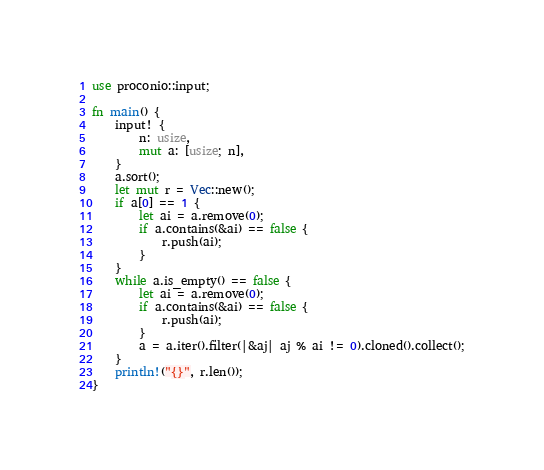Convert code to text. <code><loc_0><loc_0><loc_500><loc_500><_Rust_>use proconio::input;

fn main() {
    input! {
        n: usize,
        mut a: [usize; n],
    }
    a.sort();
    let mut r = Vec::new();
    if a[0] == 1 {
        let ai = a.remove(0);
        if a.contains(&ai) == false {
            r.push(ai);
        }
    }
    while a.is_empty() == false {
        let ai = a.remove(0);
        if a.contains(&ai) == false {
            r.push(ai);
        }
        a = a.iter().filter(|&aj| aj % ai != 0).cloned().collect();
    }
    println!("{}", r.len());
}
</code> 